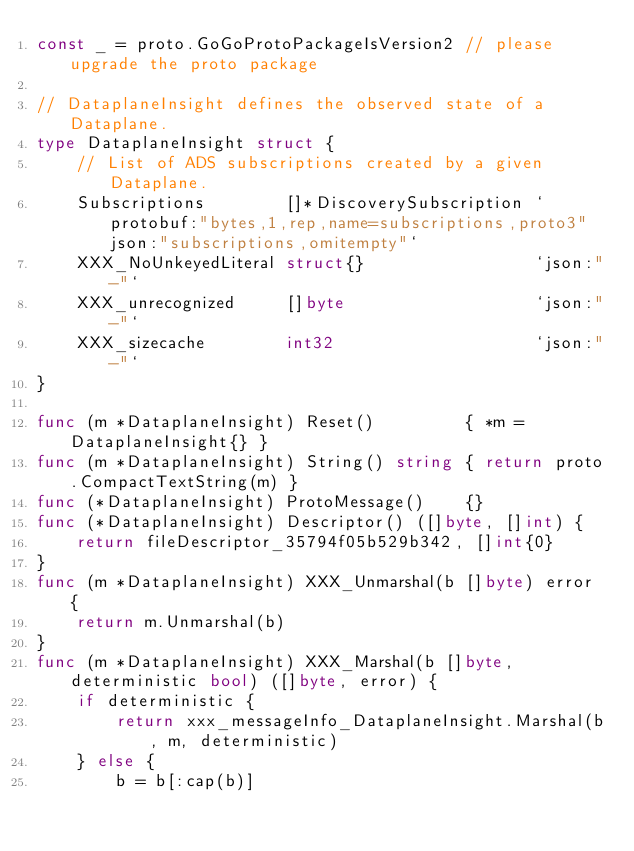Convert code to text. <code><loc_0><loc_0><loc_500><loc_500><_Go_>const _ = proto.GoGoProtoPackageIsVersion2 // please upgrade the proto package

// DataplaneInsight defines the observed state of a Dataplane.
type DataplaneInsight struct {
	// List of ADS subscriptions created by a given Dataplane.
	Subscriptions        []*DiscoverySubscription `protobuf:"bytes,1,rep,name=subscriptions,proto3" json:"subscriptions,omitempty"`
	XXX_NoUnkeyedLiteral struct{}                 `json:"-"`
	XXX_unrecognized     []byte                   `json:"-"`
	XXX_sizecache        int32                    `json:"-"`
}

func (m *DataplaneInsight) Reset()         { *m = DataplaneInsight{} }
func (m *DataplaneInsight) String() string { return proto.CompactTextString(m) }
func (*DataplaneInsight) ProtoMessage()    {}
func (*DataplaneInsight) Descriptor() ([]byte, []int) {
	return fileDescriptor_35794f05b529b342, []int{0}
}
func (m *DataplaneInsight) XXX_Unmarshal(b []byte) error {
	return m.Unmarshal(b)
}
func (m *DataplaneInsight) XXX_Marshal(b []byte, deterministic bool) ([]byte, error) {
	if deterministic {
		return xxx_messageInfo_DataplaneInsight.Marshal(b, m, deterministic)
	} else {
		b = b[:cap(b)]</code> 